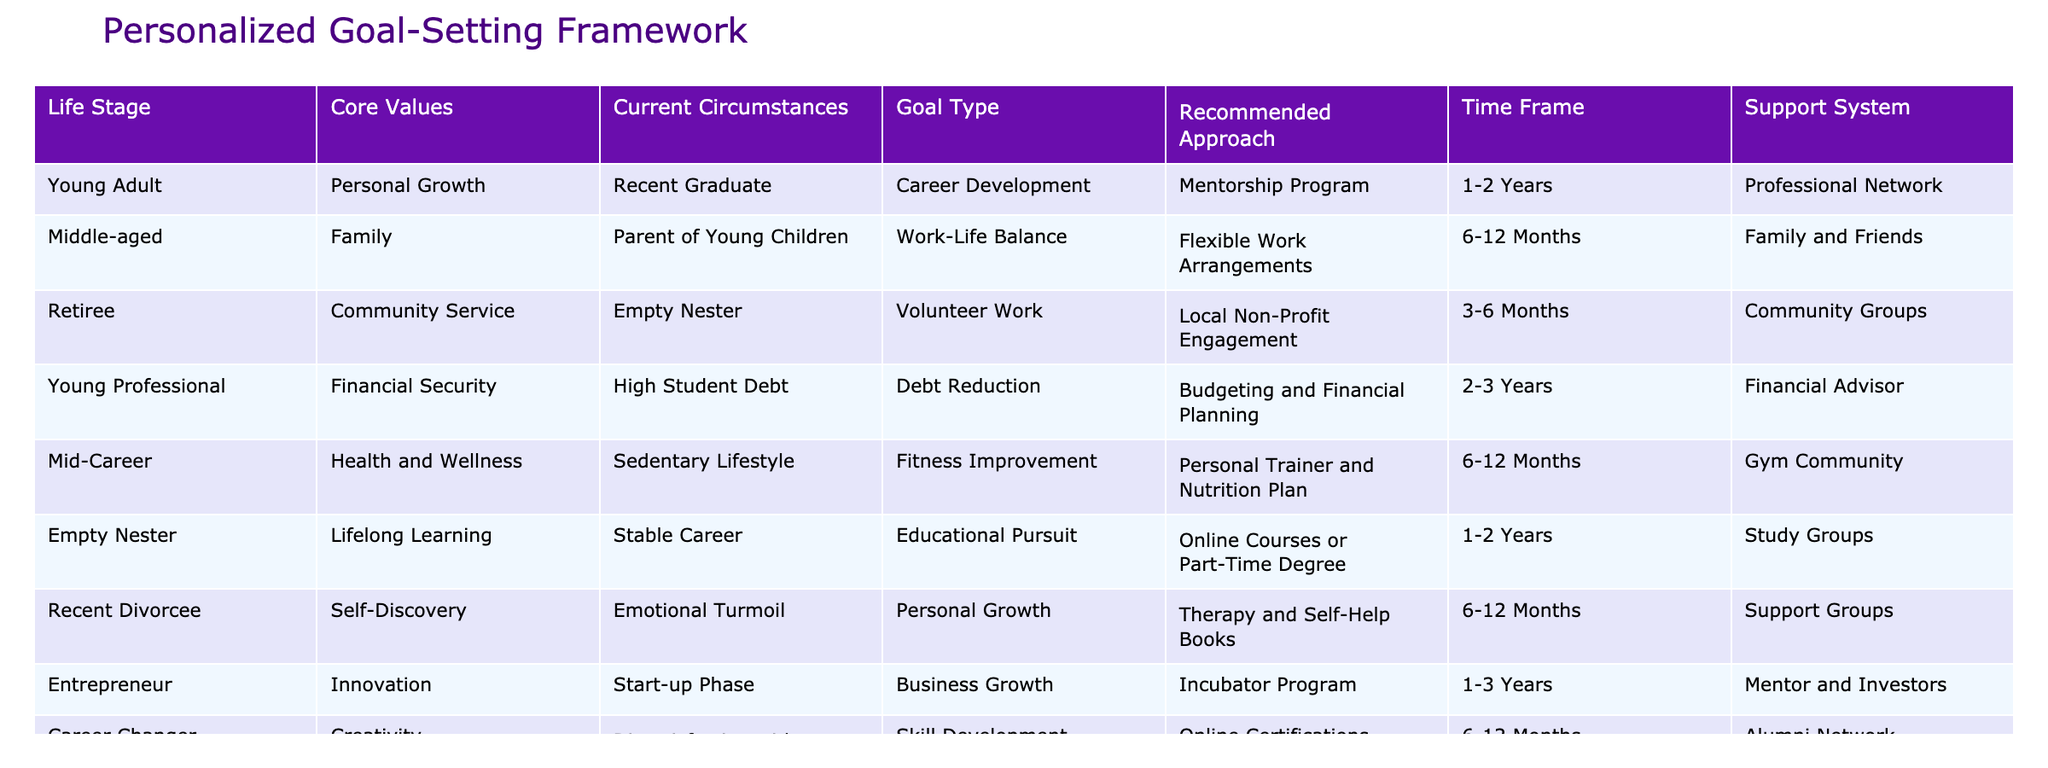What is the recommended approach for a young adult focused on career development? The table shows that a young adult with a focus on career development should consider a mentorship program. This can be directly referenced from the "Recommended Approach" column for the "Young Adult" life stage under "Career Development."
Answer: Mentorship program How long should a mid-career individual expect to see results from a fitness improvement goal? According to the table, individuals in the mid-career stage that focus on fitness improvement are advised to have a time frame of 6-12 months to see results. This time frame is listed under the "Time Frame" column corresponding to the "Mid-Career" row.
Answer: 6-12 months Is family and friends listed as a support system for a recent divorcee? The table indicates that a recent divorcee should seek support groups, not family and friends, which can be found under the "Support System" column for the "Recent Divorcee" row.
Answer: No What types of goals are recommended for empty nesters, and how long is the suggested time frame? For empty nesters, the goal type indicated is educational pursuit, and the recommended time frame to achieve this is 1-2 years. This information is gathered from the "Goal Type" and "Time Frame" columns corresponding to the "Empty Nester" life stage.
Answer: Educational pursuit, 1-2 years How many individuals focus on personal growth in the current circumstances described in the table? The table shows that there are two individuals focused on personal growth: the "Young Adult" and the "Recent Divorcee." By counting the instances of "Personal Growth" in the "Core Values," we reach the total of 2.
Answer: 2 For a young professional with high student debt, what is the recommended approach, and how long is the time frame? The young professional with high student debt should pursue budgeting and financial planning as the recommended approach, with an expected time frame of 2-3 years. This information can be located in the "Recommended Approach" and "Time Frame" columns for the "Young Professional" row.
Answer: Budgeting and financial planning, 2-3 years Is there an individual in the table requiring language proficiency as a goal type? Yes, the table indicates that a new immigrant focuses on language proficiency as their goal type. This can be verified directly from the "Goal Type" column under the "New Immigrant" row.
Answer: Yes What are the core values associated with the entrepreneur's current circumstances? The core values for the entrepreneur's current circumstances are identified as innovation, which can be directly pulled from the "Core Values" column corresponding to the "Entrepreneur" row.
Answer: Innovation For individuals seeking personal growth, how many are advised to work with therapists or self-help books? The table specifies that only one individual (the recent divorcee) suggests using therapy and self-help books, which is discernable from the facts presented under the "Goal Type" column. Thus, the total is 1 individual.
Answer: 1 